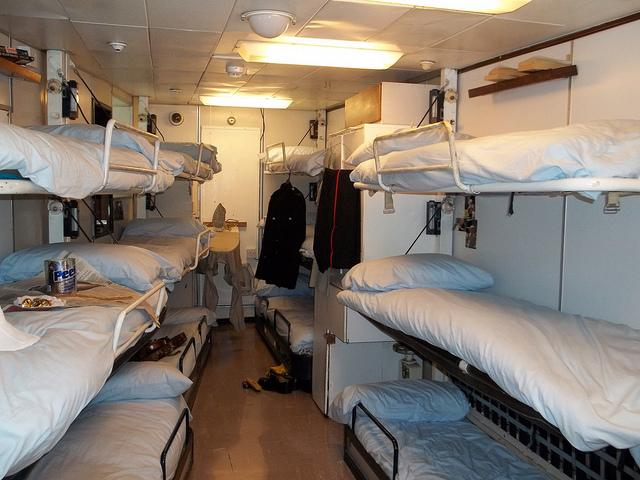Who likely resides here?

Choices:
A) newlywed couple
B) army trainees
C) bachelor
D) two roommates army trainees 